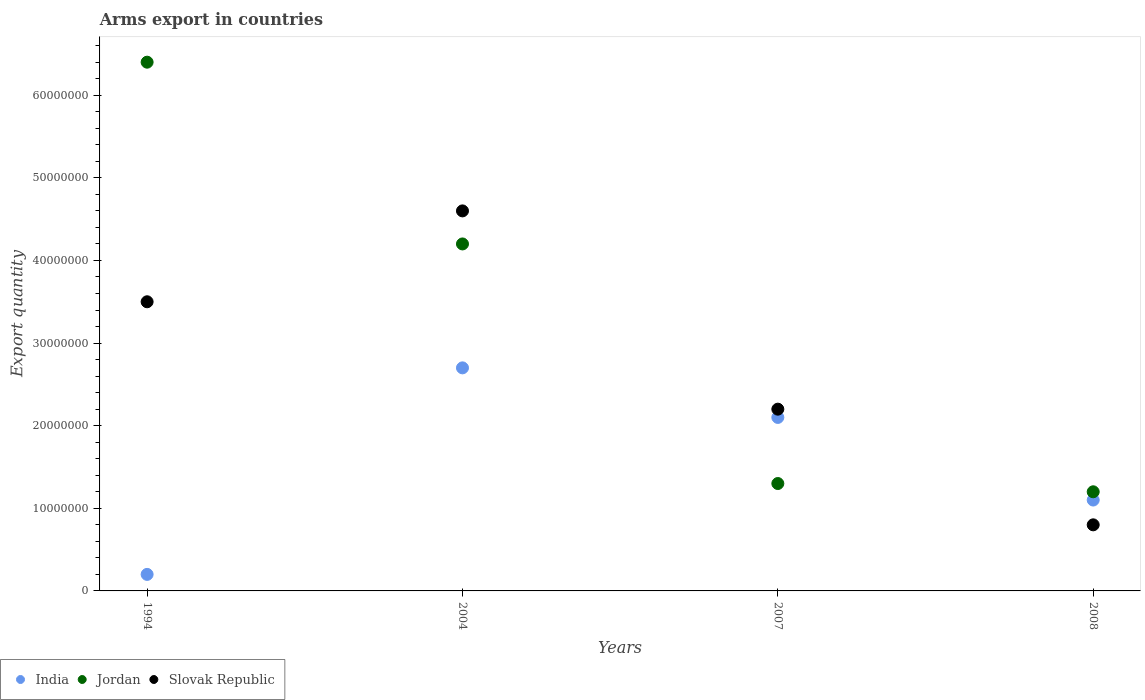Is the number of dotlines equal to the number of legend labels?
Your response must be concise. Yes. What is the total arms export in India in 1994?
Provide a short and direct response. 2.00e+06. Across all years, what is the maximum total arms export in Slovak Republic?
Offer a very short reply. 4.60e+07. Across all years, what is the minimum total arms export in India?
Keep it short and to the point. 2.00e+06. In which year was the total arms export in Jordan maximum?
Your answer should be very brief. 1994. What is the total total arms export in India in the graph?
Provide a succinct answer. 6.10e+07. What is the difference between the total arms export in Slovak Republic in 1994 and that in 2007?
Keep it short and to the point. 1.30e+07. What is the difference between the total arms export in Jordan in 2004 and the total arms export in India in 2008?
Offer a very short reply. 3.10e+07. What is the average total arms export in India per year?
Ensure brevity in your answer.  1.52e+07. In how many years, is the total arms export in Slovak Republic greater than 44000000?
Offer a terse response. 1. What is the ratio of the total arms export in Jordan in 2007 to that in 2008?
Your answer should be compact. 1.08. Is the difference between the total arms export in Slovak Republic in 2007 and 2008 greater than the difference between the total arms export in Jordan in 2007 and 2008?
Your response must be concise. Yes. What is the difference between the highest and the second highest total arms export in Slovak Republic?
Make the answer very short. 1.10e+07. What is the difference between the highest and the lowest total arms export in Slovak Republic?
Offer a terse response. 3.80e+07. In how many years, is the total arms export in Jordan greater than the average total arms export in Jordan taken over all years?
Ensure brevity in your answer.  2. Is the sum of the total arms export in Slovak Republic in 1994 and 2004 greater than the maximum total arms export in India across all years?
Your answer should be compact. Yes. Is it the case that in every year, the sum of the total arms export in Jordan and total arms export in India  is greater than the total arms export in Slovak Republic?
Make the answer very short. Yes. Does the total arms export in Slovak Republic monotonically increase over the years?
Give a very brief answer. No. What is the difference between two consecutive major ticks on the Y-axis?
Ensure brevity in your answer.  1.00e+07. Are the values on the major ticks of Y-axis written in scientific E-notation?
Your answer should be very brief. No. Does the graph contain any zero values?
Give a very brief answer. No. Where does the legend appear in the graph?
Make the answer very short. Bottom left. How many legend labels are there?
Your response must be concise. 3. What is the title of the graph?
Ensure brevity in your answer.  Arms export in countries. What is the label or title of the X-axis?
Ensure brevity in your answer.  Years. What is the label or title of the Y-axis?
Ensure brevity in your answer.  Export quantity. What is the Export quantity of India in 1994?
Make the answer very short. 2.00e+06. What is the Export quantity in Jordan in 1994?
Make the answer very short. 6.40e+07. What is the Export quantity of Slovak Republic in 1994?
Keep it short and to the point. 3.50e+07. What is the Export quantity in India in 2004?
Your response must be concise. 2.70e+07. What is the Export quantity of Jordan in 2004?
Offer a terse response. 4.20e+07. What is the Export quantity of Slovak Republic in 2004?
Offer a very short reply. 4.60e+07. What is the Export quantity in India in 2007?
Offer a very short reply. 2.10e+07. What is the Export quantity of Jordan in 2007?
Give a very brief answer. 1.30e+07. What is the Export quantity of Slovak Republic in 2007?
Keep it short and to the point. 2.20e+07. What is the Export quantity of India in 2008?
Your response must be concise. 1.10e+07. What is the Export quantity of Slovak Republic in 2008?
Make the answer very short. 8.00e+06. Across all years, what is the maximum Export quantity of India?
Provide a short and direct response. 2.70e+07. Across all years, what is the maximum Export quantity of Jordan?
Make the answer very short. 6.40e+07. Across all years, what is the maximum Export quantity of Slovak Republic?
Your answer should be compact. 4.60e+07. Across all years, what is the minimum Export quantity of Jordan?
Give a very brief answer. 1.20e+07. Across all years, what is the minimum Export quantity in Slovak Republic?
Ensure brevity in your answer.  8.00e+06. What is the total Export quantity of India in the graph?
Keep it short and to the point. 6.10e+07. What is the total Export quantity in Jordan in the graph?
Keep it short and to the point. 1.31e+08. What is the total Export quantity of Slovak Republic in the graph?
Keep it short and to the point. 1.11e+08. What is the difference between the Export quantity in India in 1994 and that in 2004?
Offer a terse response. -2.50e+07. What is the difference between the Export quantity in Jordan in 1994 and that in 2004?
Provide a succinct answer. 2.20e+07. What is the difference between the Export quantity in Slovak Republic in 1994 and that in 2004?
Your answer should be very brief. -1.10e+07. What is the difference between the Export quantity in India in 1994 and that in 2007?
Provide a succinct answer. -1.90e+07. What is the difference between the Export quantity in Jordan in 1994 and that in 2007?
Offer a terse response. 5.10e+07. What is the difference between the Export quantity of Slovak Republic in 1994 and that in 2007?
Ensure brevity in your answer.  1.30e+07. What is the difference between the Export quantity of India in 1994 and that in 2008?
Keep it short and to the point. -9.00e+06. What is the difference between the Export quantity in Jordan in 1994 and that in 2008?
Provide a succinct answer. 5.20e+07. What is the difference between the Export quantity in Slovak Republic in 1994 and that in 2008?
Provide a succinct answer. 2.70e+07. What is the difference between the Export quantity of Jordan in 2004 and that in 2007?
Offer a very short reply. 2.90e+07. What is the difference between the Export quantity of Slovak Republic in 2004 and that in 2007?
Offer a terse response. 2.40e+07. What is the difference between the Export quantity of India in 2004 and that in 2008?
Offer a terse response. 1.60e+07. What is the difference between the Export quantity in Jordan in 2004 and that in 2008?
Provide a short and direct response. 3.00e+07. What is the difference between the Export quantity in Slovak Republic in 2004 and that in 2008?
Give a very brief answer. 3.80e+07. What is the difference between the Export quantity of India in 2007 and that in 2008?
Provide a succinct answer. 1.00e+07. What is the difference between the Export quantity in Jordan in 2007 and that in 2008?
Make the answer very short. 1.00e+06. What is the difference between the Export quantity in Slovak Republic in 2007 and that in 2008?
Your response must be concise. 1.40e+07. What is the difference between the Export quantity in India in 1994 and the Export quantity in Jordan in 2004?
Give a very brief answer. -4.00e+07. What is the difference between the Export quantity of India in 1994 and the Export quantity of Slovak Republic in 2004?
Ensure brevity in your answer.  -4.40e+07. What is the difference between the Export quantity in Jordan in 1994 and the Export quantity in Slovak Republic in 2004?
Your answer should be very brief. 1.80e+07. What is the difference between the Export quantity in India in 1994 and the Export quantity in Jordan in 2007?
Ensure brevity in your answer.  -1.10e+07. What is the difference between the Export quantity in India in 1994 and the Export quantity in Slovak Republic in 2007?
Provide a succinct answer. -2.00e+07. What is the difference between the Export quantity in Jordan in 1994 and the Export quantity in Slovak Republic in 2007?
Your response must be concise. 4.20e+07. What is the difference between the Export quantity in India in 1994 and the Export quantity in Jordan in 2008?
Provide a short and direct response. -1.00e+07. What is the difference between the Export quantity in India in 1994 and the Export quantity in Slovak Republic in 2008?
Your response must be concise. -6.00e+06. What is the difference between the Export quantity of Jordan in 1994 and the Export quantity of Slovak Republic in 2008?
Your response must be concise. 5.60e+07. What is the difference between the Export quantity of India in 2004 and the Export quantity of Jordan in 2007?
Offer a terse response. 1.40e+07. What is the difference between the Export quantity in India in 2004 and the Export quantity in Slovak Republic in 2007?
Offer a terse response. 5.00e+06. What is the difference between the Export quantity of India in 2004 and the Export quantity of Jordan in 2008?
Provide a short and direct response. 1.50e+07. What is the difference between the Export quantity in India in 2004 and the Export quantity in Slovak Republic in 2008?
Provide a short and direct response. 1.90e+07. What is the difference between the Export quantity of Jordan in 2004 and the Export quantity of Slovak Republic in 2008?
Your answer should be very brief. 3.40e+07. What is the difference between the Export quantity in India in 2007 and the Export quantity in Jordan in 2008?
Keep it short and to the point. 9.00e+06. What is the difference between the Export quantity of India in 2007 and the Export quantity of Slovak Republic in 2008?
Ensure brevity in your answer.  1.30e+07. What is the difference between the Export quantity of Jordan in 2007 and the Export quantity of Slovak Republic in 2008?
Give a very brief answer. 5.00e+06. What is the average Export quantity of India per year?
Your response must be concise. 1.52e+07. What is the average Export quantity in Jordan per year?
Provide a succinct answer. 3.28e+07. What is the average Export quantity in Slovak Republic per year?
Your answer should be very brief. 2.78e+07. In the year 1994, what is the difference between the Export quantity of India and Export quantity of Jordan?
Give a very brief answer. -6.20e+07. In the year 1994, what is the difference between the Export quantity in India and Export quantity in Slovak Republic?
Keep it short and to the point. -3.30e+07. In the year 1994, what is the difference between the Export quantity in Jordan and Export quantity in Slovak Republic?
Ensure brevity in your answer.  2.90e+07. In the year 2004, what is the difference between the Export quantity in India and Export quantity in Jordan?
Make the answer very short. -1.50e+07. In the year 2004, what is the difference between the Export quantity of India and Export quantity of Slovak Republic?
Ensure brevity in your answer.  -1.90e+07. In the year 2004, what is the difference between the Export quantity of Jordan and Export quantity of Slovak Republic?
Keep it short and to the point. -4.00e+06. In the year 2007, what is the difference between the Export quantity in India and Export quantity in Jordan?
Provide a short and direct response. 8.00e+06. In the year 2007, what is the difference between the Export quantity in India and Export quantity in Slovak Republic?
Your response must be concise. -1.00e+06. In the year 2007, what is the difference between the Export quantity in Jordan and Export quantity in Slovak Republic?
Make the answer very short. -9.00e+06. In the year 2008, what is the difference between the Export quantity of India and Export quantity of Jordan?
Your response must be concise. -1.00e+06. What is the ratio of the Export quantity of India in 1994 to that in 2004?
Provide a short and direct response. 0.07. What is the ratio of the Export quantity in Jordan in 1994 to that in 2004?
Give a very brief answer. 1.52. What is the ratio of the Export quantity in Slovak Republic in 1994 to that in 2004?
Keep it short and to the point. 0.76. What is the ratio of the Export quantity in India in 1994 to that in 2007?
Your answer should be compact. 0.1. What is the ratio of the Export quantity of Jordan in 1994 to that in 2007?
Your answer should be very brief. 4.92. What is the ratio of the Export quantity of Slovak Republic in 1994 to that in 2007?
Provide a short and direct response. 1.59. What is the ratio of the Export quantity in India in 1994 to that in 2008?
Make the answer very short. 0.18. What is the ratio of the Export quantity of Jordan in 1994 to that in 2008?
Your response must be concise. 5.33. What is the ratio of the Export quantity of Slovak Republic in 1994 to that in 2008?
Your answer should be very brief. 4.38. What is the ratio of the Export quantity of Jordan in 2004 to that in 2007?
Provide a short and direct response. 3.23. What is the ratio of the Export quantity in Slovak Republic in 2004 to that in 2007?
Keep it short and to the point. 2.09. What is the ratio of the Export quantity in India in 2004 to that in 2008?
Your answer should be compact. 2.45. What is the ratio of the Export quantity in Jordan in 2004 to that in 2008?
Ensure brevity in your answer.  3.5. What is the ratio of the Export quantity in Slovak Republic in 2004 to that in 2008?
Offer a terse response. 5.75. What is the ratio of the Export quantity of India in 2007 to that in 2008?
Ensure brevity in your answer.  1.91. What is the ratio of the Export quantity of Slovak Republic in 2007 to that in 2008?
Provide a short and direct response. 2.75. What is the difference between the highest and the second highest Export quantity of Jordan?
Provide a short and direct response. 2.20e+07. What is the difference between the highest and the second highest Export quantity of Slovak Republic?
Ensure brevity in your answer.  1.10e+07. What is the difference between the highest and the lowest Export quantity of India?
Keep it short and to the point. 2.50e+07. What is the difference between the highest and the lowest Export quantity of Jordan?
Ensure brevity in your answer.  5.20e+07. What is the difference between the highest and the lowest Export quantity of Slovak Republic?
Provide a short and direct response. 3.80e+07. 